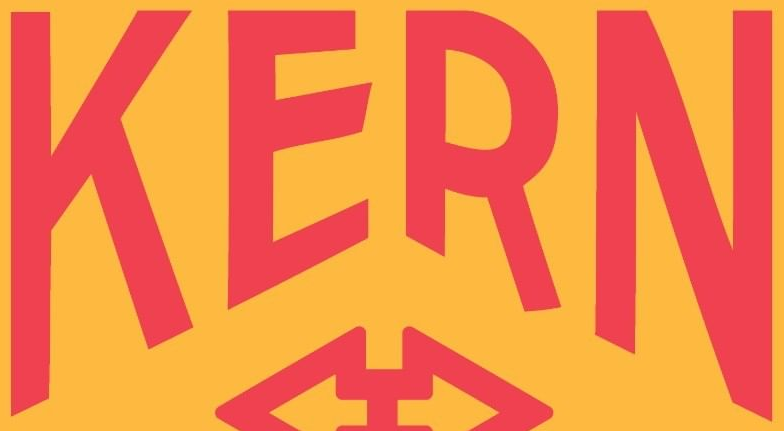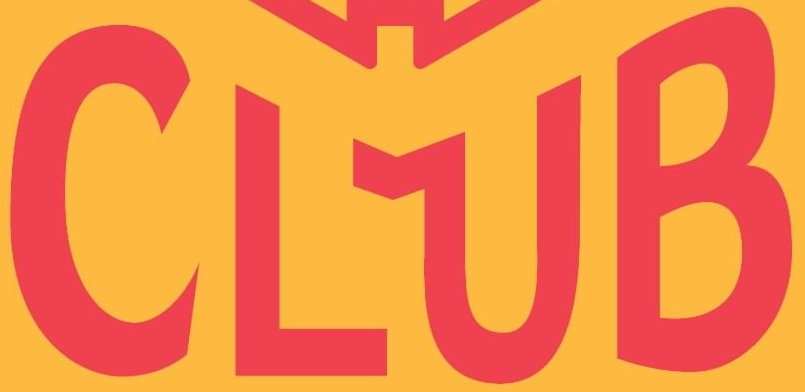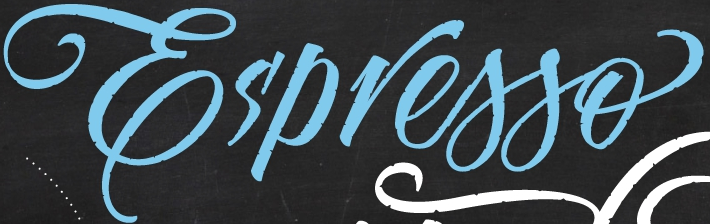Read the text content from these images in order, separated by a semicolon. KERN; CLUB; Es'presso 